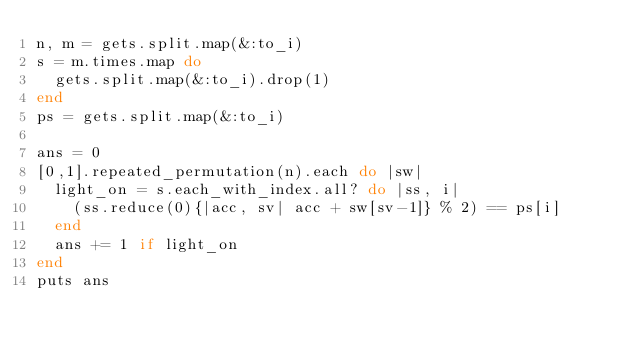Convert code to text. <code><loc_0><loc_0><loc_500><loc_500><_Ruby_>n, m = gets.split.map(&:to_i)
s = m.times.map do
  gets.split.map(&:to_i).drop(1)
end
ps = gets.split.map(&:to_i)

ans = 0
[0,1].repeated_permutation(n).each do |sw|
  light_on = s.each_with_index.all? do |ss, i|
    (ss.reduce(0){|acc, sv| acc + sw[sv-1]} % 2) == ps[i]
  end
  ans += 1 if light_on
end
puts ans
</code> 